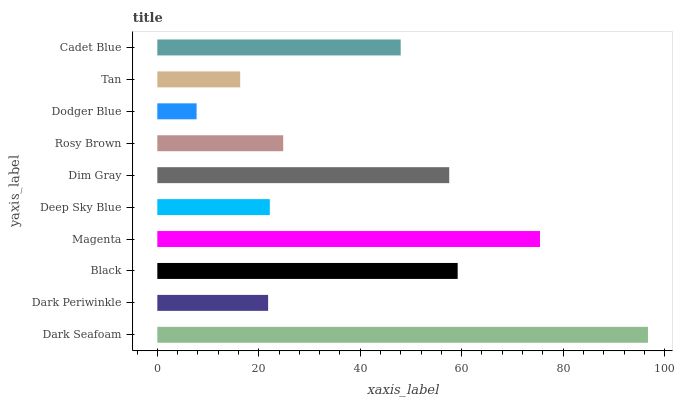Is Dodger Blue the minimum?
Answer yes or no. Yes. Is Dark Seafoam the maximum?
Answer yes or no. Yes. Is Dark Periwinkle the minimum?
Answer yes or no. No. Is Dark Periwinkle the maximum?
Answer yes or no. No. Is Dark Seafoam greater than Dark Periwinkle?
Answer yes or no. Yes. Is Dark Periwinkle less than Dark Seafoam?
Answer yes or no. Yes. Is Dark Periwinkle greater than Dark Seafoam?
Answer yes or no. No. Is Dark Seafoam less than Dark Periwinkle?
Answer yes or no. No. Is Cadet Blue the high median?
Answer yes or no. Yes. Is Rosy Brown the low median?
Answer yes or no. Yes. Is Deep Sky Blue the high median?
Answer yes or no. No. Is Dim Gray the low median?
Answer yes or no. No. 